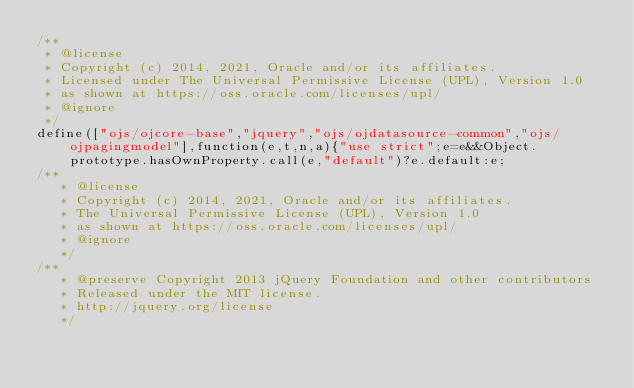<code> <loc_0><loc_0><loc_500><loc_500><_JavaScript_>/**
 * @license
 * Copyright (c) 2014, 2021, Oracle and/or its affiliates.
 * Licensed under The Universal Permissive License (UPL), Version 1.0
 * as shown at https://oss.oracle.com/licenses/upl/
 * @ignore
 */
define(["ojs/ojcore-base","jquery","ojs/ojdatasource-common","ojs/ojpagingmodel"],function(e,t,n,a){"use strict";e=e&&Object.prototype.hasOwnProperty.call(e,"default")?e.default:e;
/**
   * @license
   * Copyright (c) 2014, 2021, Oracle and/or its affiliates.
   * The Universal Permissive License (UPL), Version 1.0
   * as shown at https://oss.oracle.com/licenses/upl/
   * @ignore
   */
/**
   * @preserve Copyright 2013 jQuery Foundation and other contributors
   * Released under the MIT license.
   * http://jquery.org/license
   */</code> 